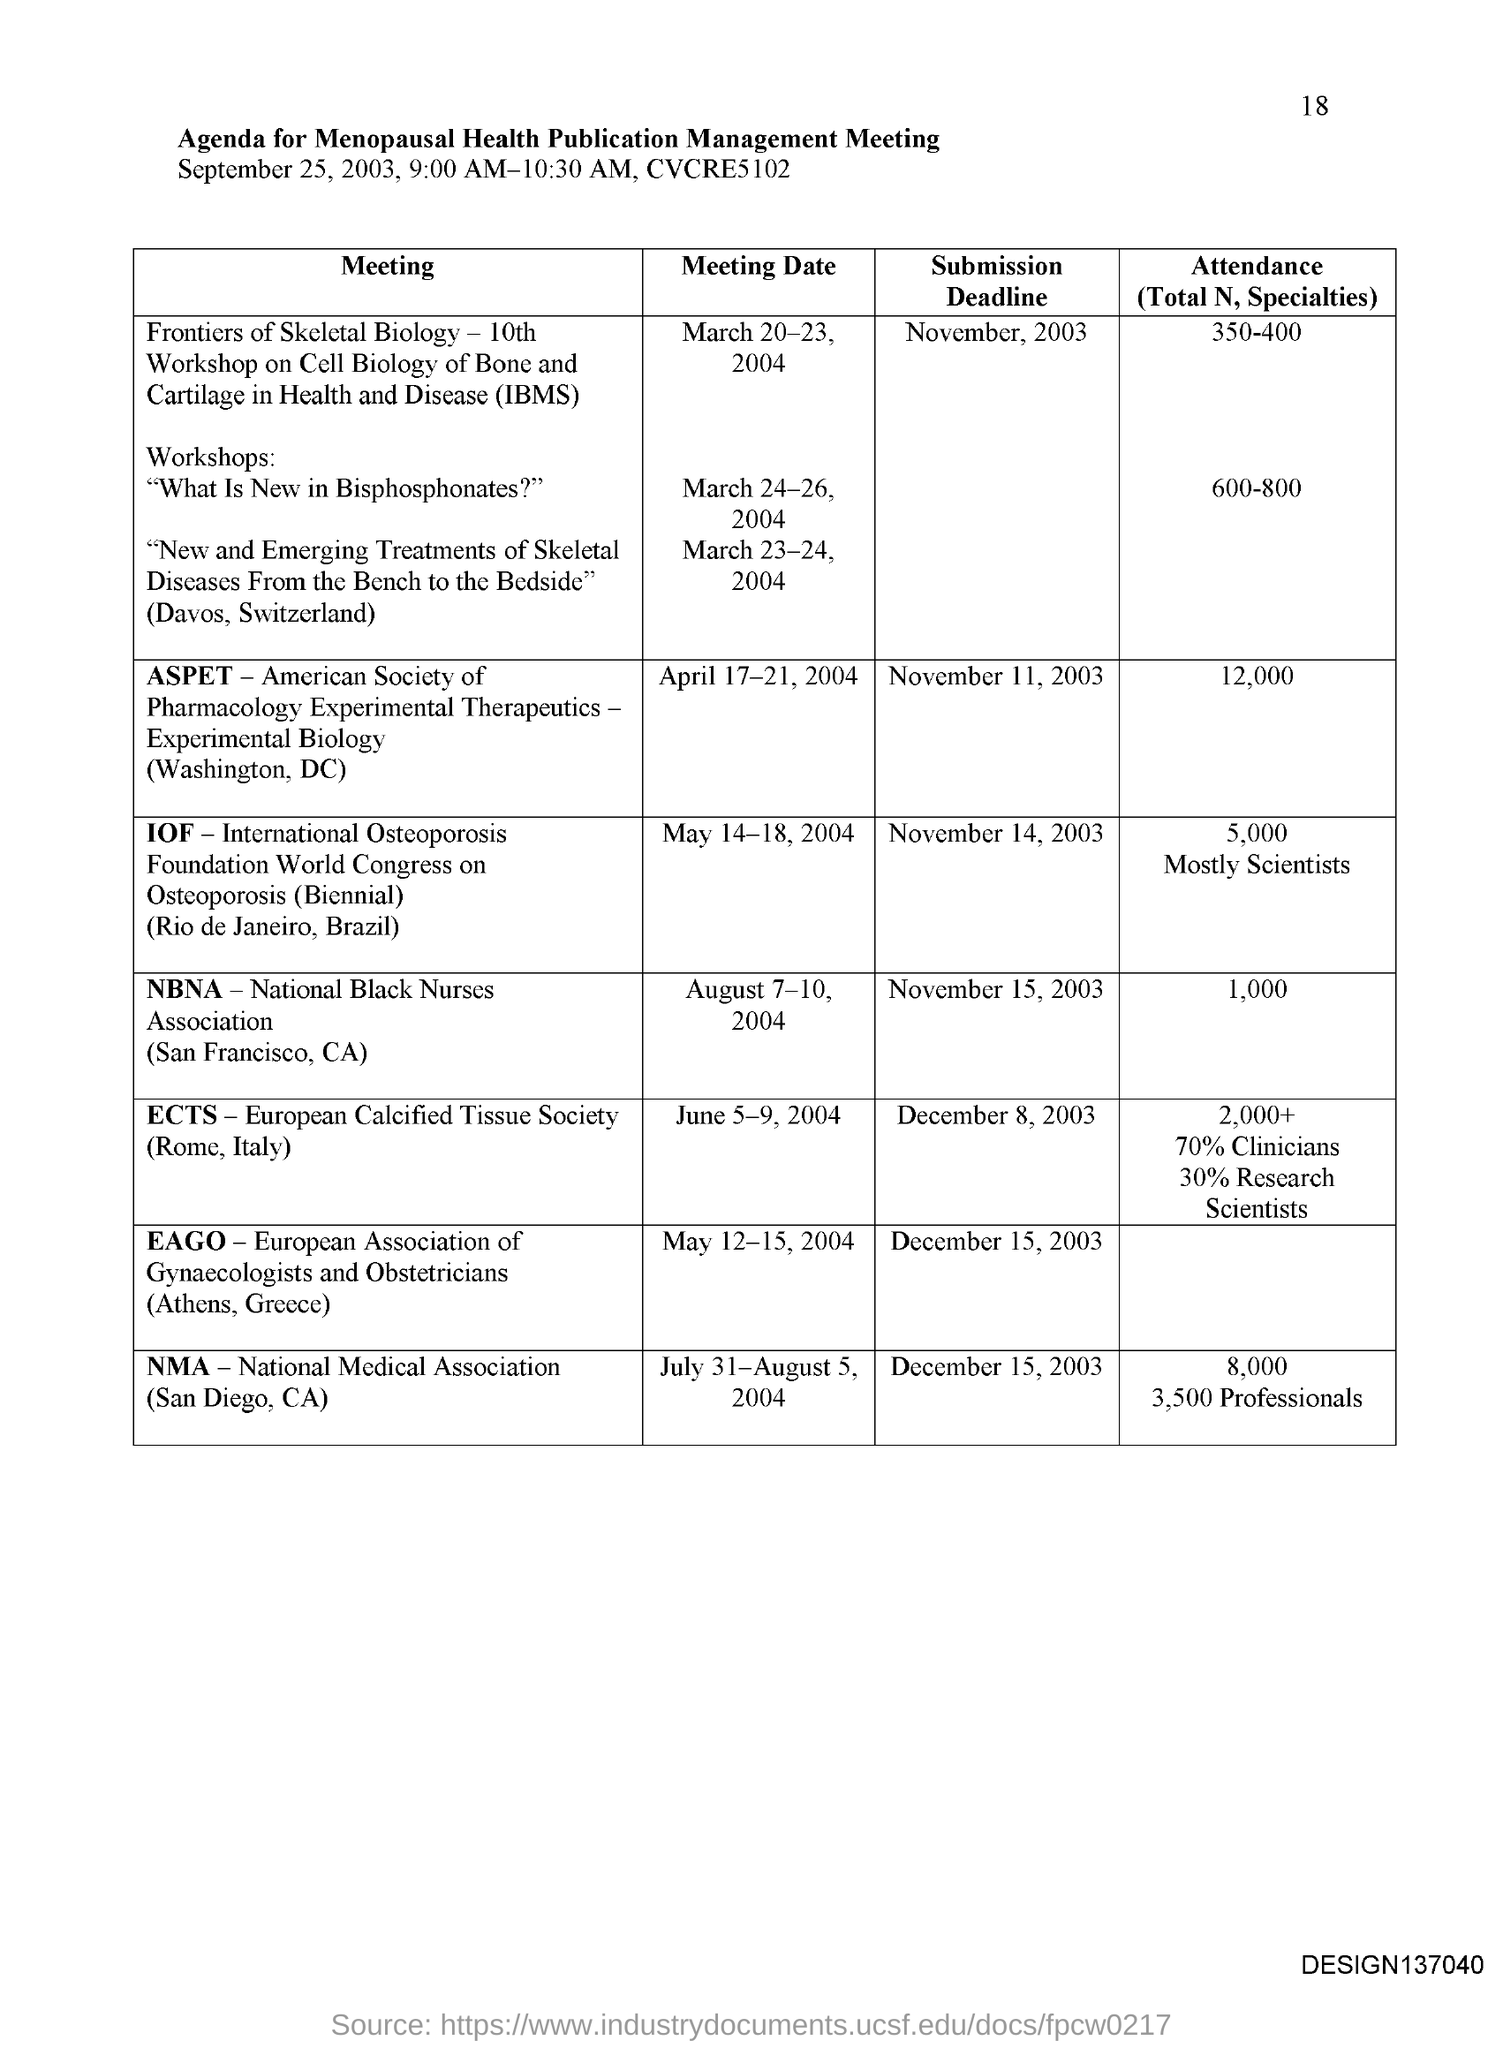Indicate a few pertinent items in this graphic. The abbreviation for "International Osteoporosis Foundation" is IOF. The abbreviation for ECTS is European Calcified Tissue Society. The meeting date for ASPET is April 17-21, 2004. The meeting date for the National Black Nurses Association is August 7-10, 2004. The abbreviation for NMA is National Medical Association. 